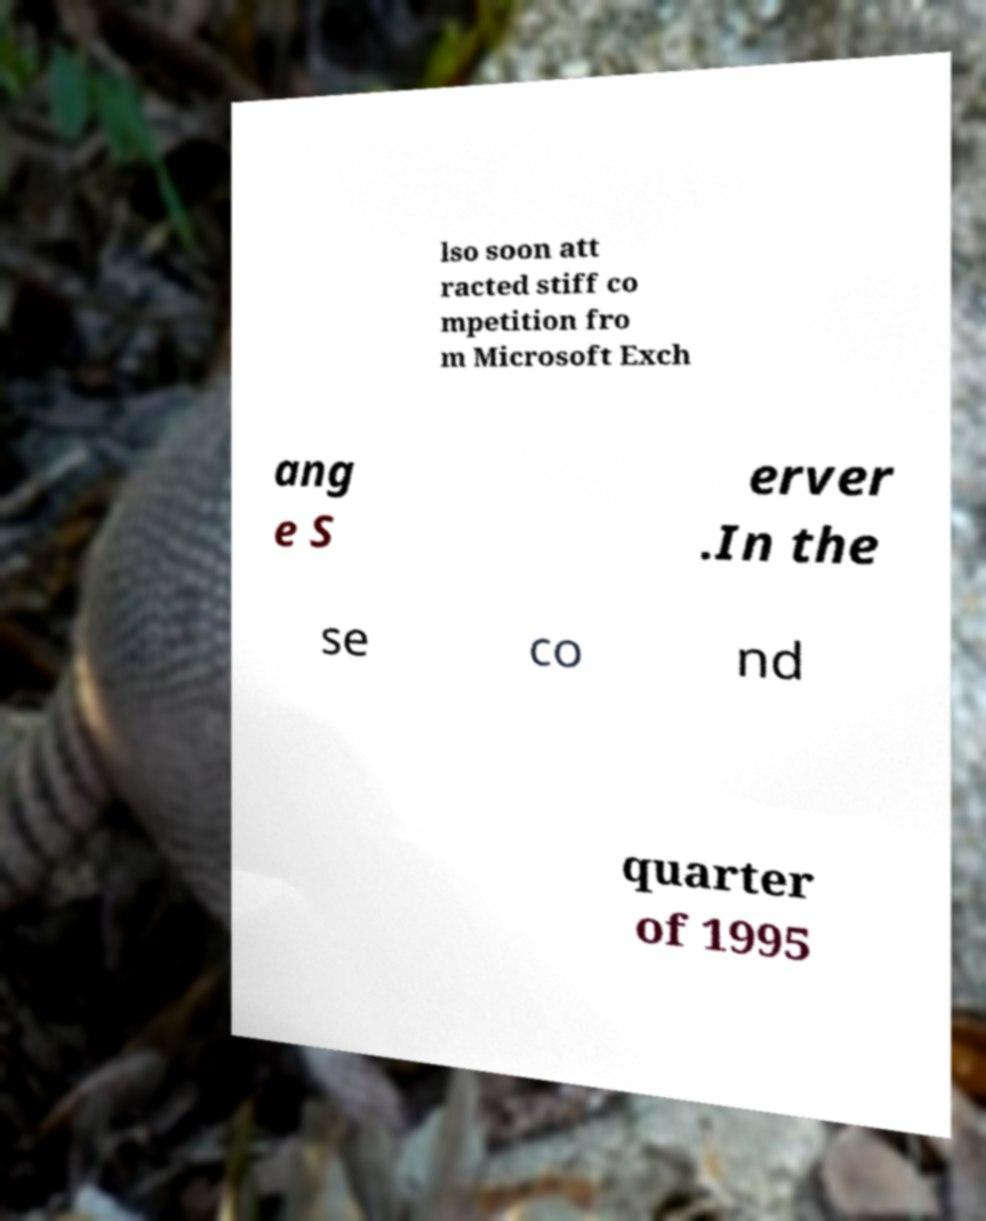Can you read and provide the text displayed in the image?This photo seems to have some interesting text. Can you extract and type it out for me? lso soon att racted stiff co mpetition fro m Microsoft Exch ang e S erver .In the se co nd quarter of 1995 